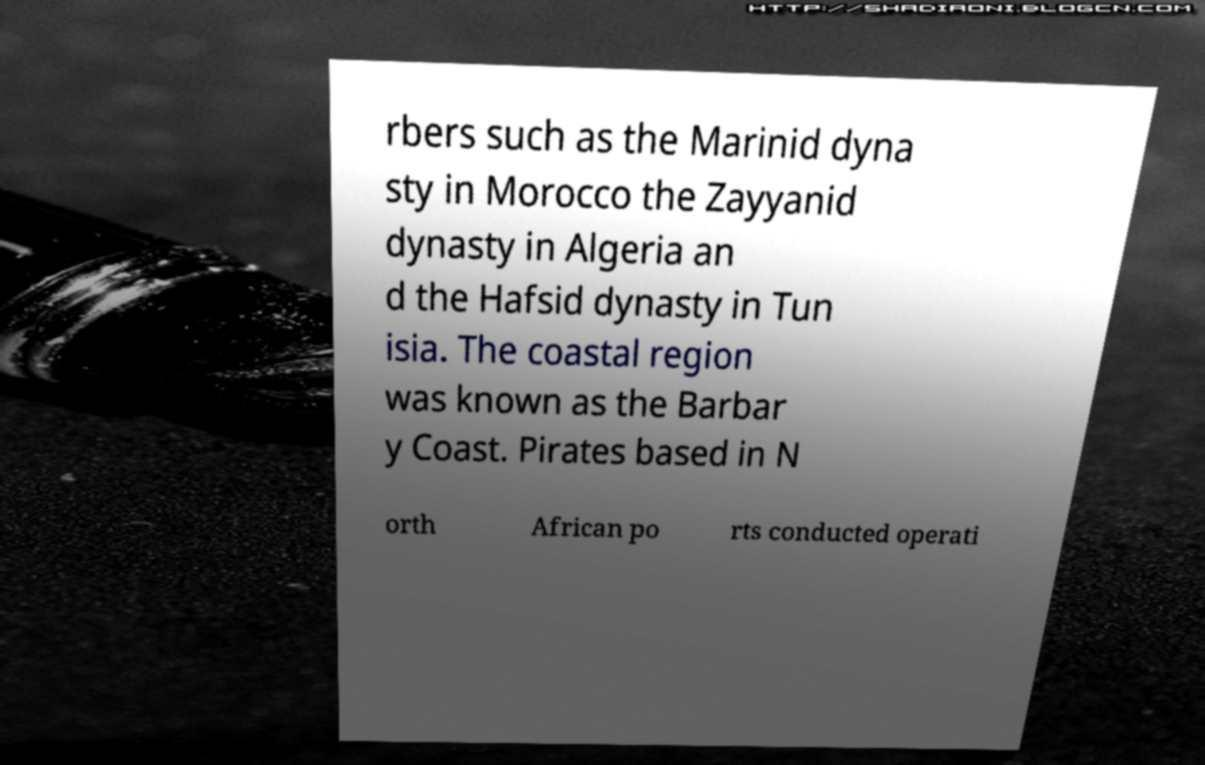Please read and relay the text visible in this image. What does it say? rbers such as the Marinid dyna sty in Morocco the Zayyanid dynasty in Algeria an d the Hafsid dynasty in Tun isia. The coastal region was known as the Barbar y Coast. Pirates based in N orth African po rts conducted operati 